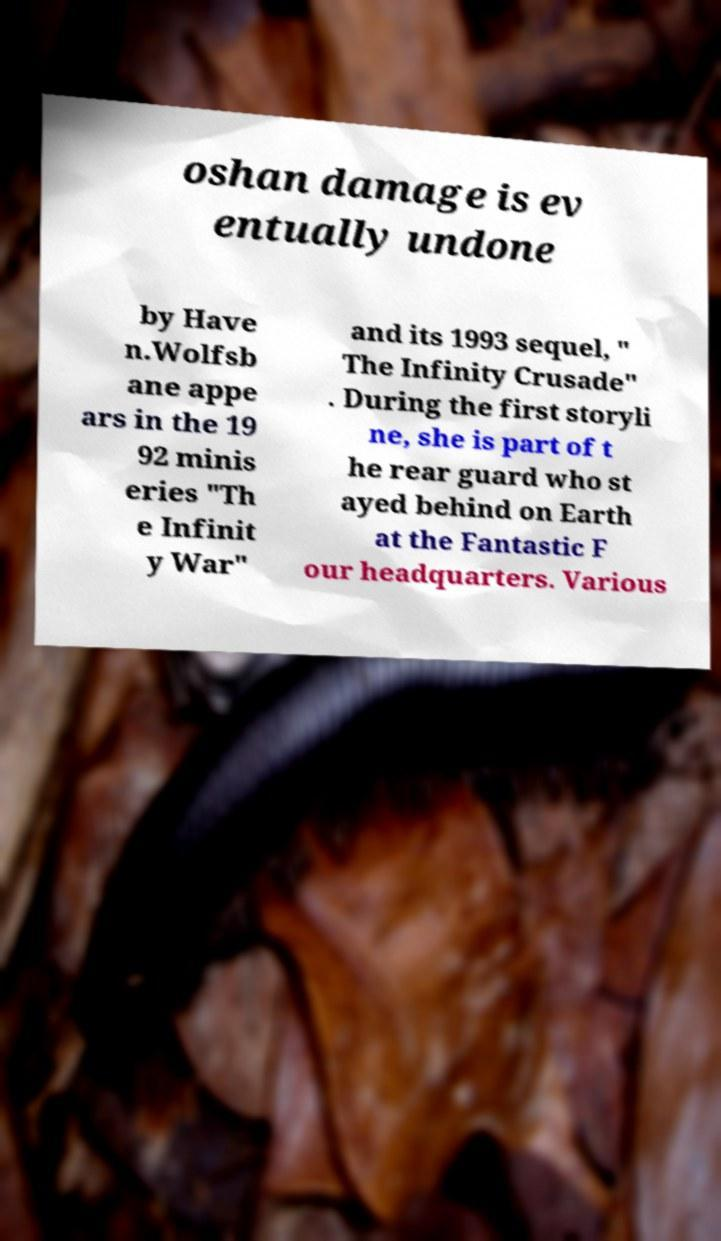Can you read and provide the text displayed in the image?This photo seems to have some interesting text. Can you extract and type it out for me? oshan damage is ev entually undone by Have n.Wolfsb ane appe ars in the 19 92 minis eries "Th e Infinit y War" and its 1993 sequel, " The Infinity Crusade" . During the first storyli ne, she is part of t he rear guard who st ayed behind on Earth at the Fantastic F our headquarters. Various 